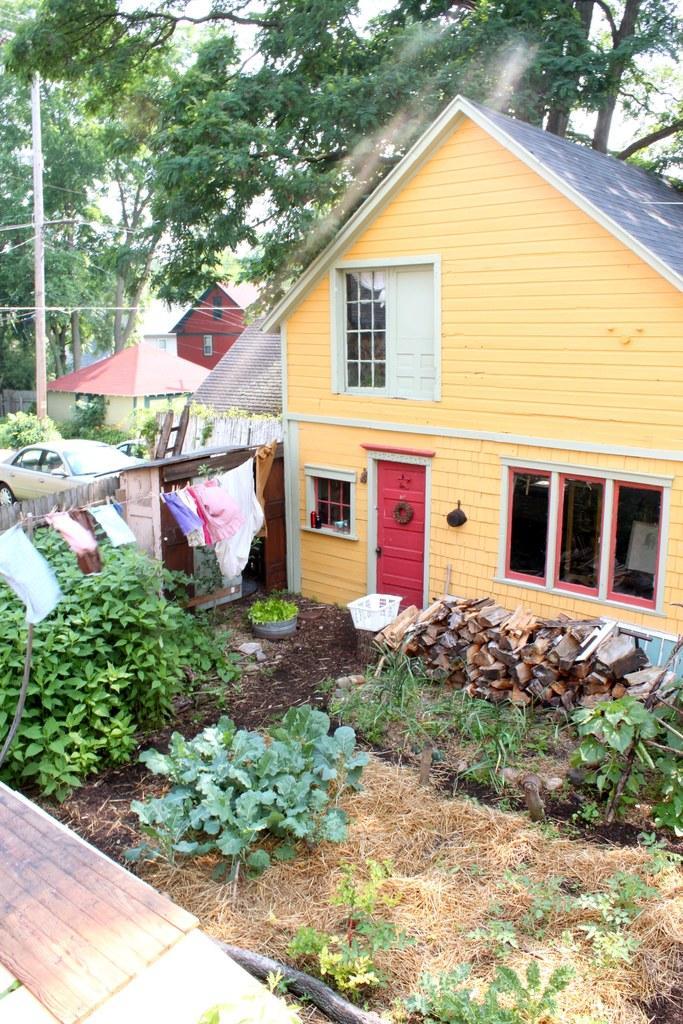Could you give a brief overview of what you see in this image? In this image I can see few plants, some grass, few wooden logs, few clothes hanged to the rope, a house, a red colored door, a vehicle, a white colored basket, a pole, few trees, few other buildings and the sky in the background. 